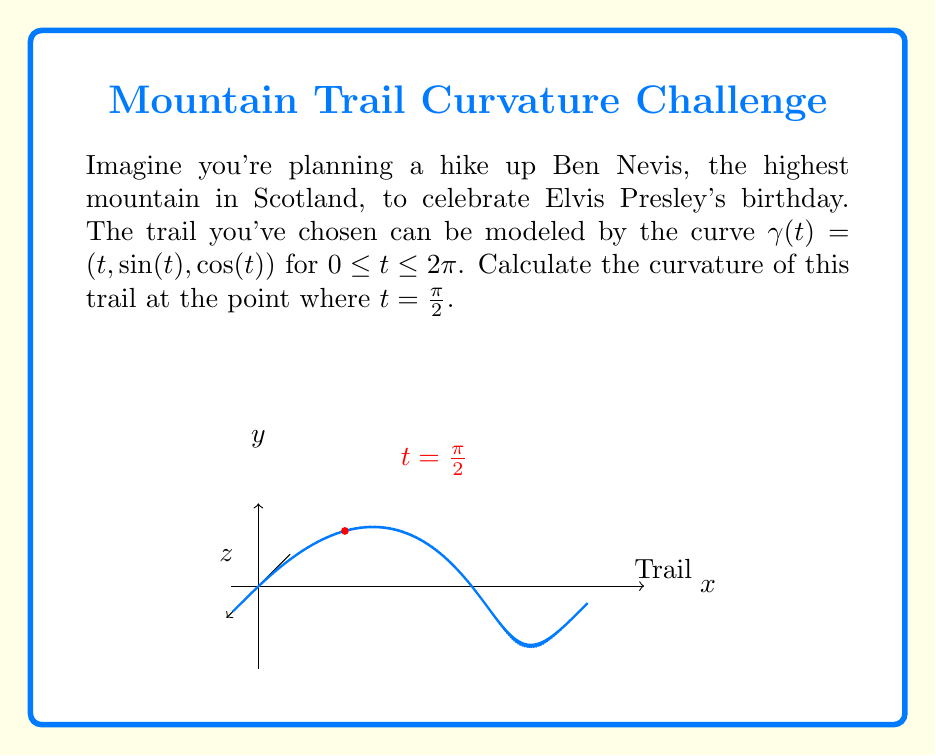Give your solution to this math problem. Let's approach this step-by-step using differential geometry:

1) The curvature $\kappa$ of a curve $\gamma(t)$ is given by:

   $$\kappa = \frac{|\gamma'(t) \times \gamma''(t)|}{|\gamma'(t)|^3}$$

2) We need to calculate $\gamma'(t)$ and $\gamma''(t)$:
   
   $$\gamma'(t) = (1, \cos(t), -\sin(t))$$
   $$\gamma''(t) = (0, -\sin(t), -\cos(t))$$

3) At $t = \frac{\pi}{2}$:
   
   $$\gamma'(\frac{\pi}{2}) = (1, 0, -1)$$
   $$\gamma''(\frac{\pi}{2}) = (0, -1, 0)$$

4) Now, let's calculate the cross product $\gamma'(\frac{\pi}{2}) \times \gamma''(\frac{\pi}{2})$:
   
   $$\gamma'(\frac{\pi}{2}) \times \gamma''(\frac{\pi}{2}) = (1, 1, 1)$$

5) The magnitude of this cross product is:
   
   $$|\gamma'(\frac{\pi}{2}) \times \gamma''(\frac{\pi}{2})| = \sqrt{1^2 + 1^2 + 1^2} = \sqrt{3}$$

6) The magnitude of $\gamma'(\frac{\pi}{2})$ is:
   
   $$|\gamma'(\frac{\pi}{2})| = \sqrt{1^2 + 0^2 + (-1)^2} = \sqrt{2}$$

7) Now we can plug these values into our curvature formula:

   $$\kappa = \frac{\sqrt{3}}{(\sqrt{2})^3} = \frac{\sqrt{3}}{2\sqrt{2}}$$

8) Simplify:
   
   $$\kappa = \frac{\sqrt{6}}{4}$$
Answer: $\frac{\sqrt{6}}{4}$ 